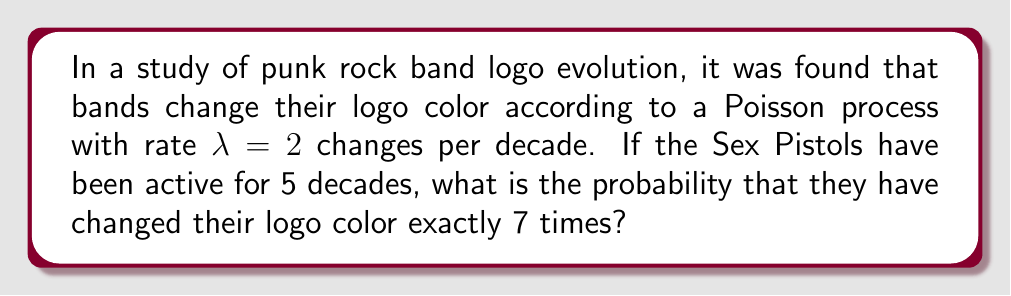Give your solution to this math problem. To solve this problem, we'll use the Poisson distribution formula:

$$P(X = k) = \frac{e^{-\lambda t}(\lambda t)^k}{k!}$$

Where:
$X$ is the number of events (logo color changes)
$k$ is the specific number of events we're interested in (7 changes)
$\lambda$ is the rate of events (2 changes per decade)
$t$ is the time period (5 decades)

Step 1: Calculate $\lambda t$
$\lambda t = 2 \text{ changes/decade} \times 5 \text{ decades} = 10$

Step 2: Plug values into the Poisson distribution formula
$$P(X = 7) = \frac{e^{-10}(10)^7}{7!}$$

Step 3: Calculate the numerator
$e^{-10} \approx 0.0000454$
$10^7 = 10,000,000$
$e^{-10}(10)^7 \approx 454$

Step 4: Calculate the denominator
$7! = 7 \times 6 \times 5 \times 4 \times 3 \times 2 \times 1 = 5040$

Step 5: Divide the numerator by the denominator
$$P(X = 7) = \frac{454}{5040} \approx 0.0901$$

Therefore, the probability of the Sex Pistols changing their logo color exactly 7 times in 5 decades is approximately 0.0901 or 9.01%.
Answer: $0.0901$ or $9.01\%$ 